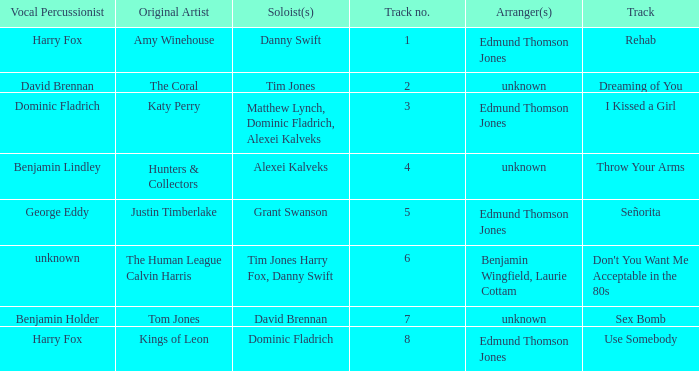Who is the artist where the vocal percussionist is Benjamin Holder? Tom Jones. 